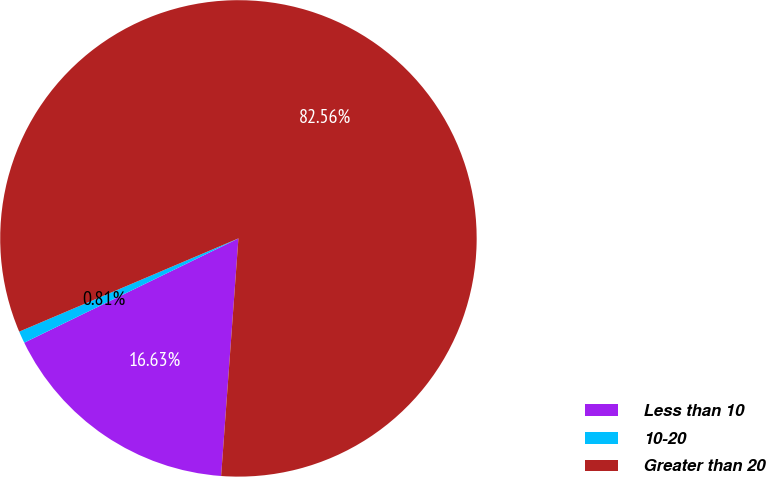Convert chart to OTSL. <chart><loc_0><loc_0><loc_500><loc_500><pie_chart><fcel>Less than 10<fcel>10-20<fcel>Greater than 20<nl><fcel>16.63%<fcel>0.81%<fcel>82.55%<nl></chart> 